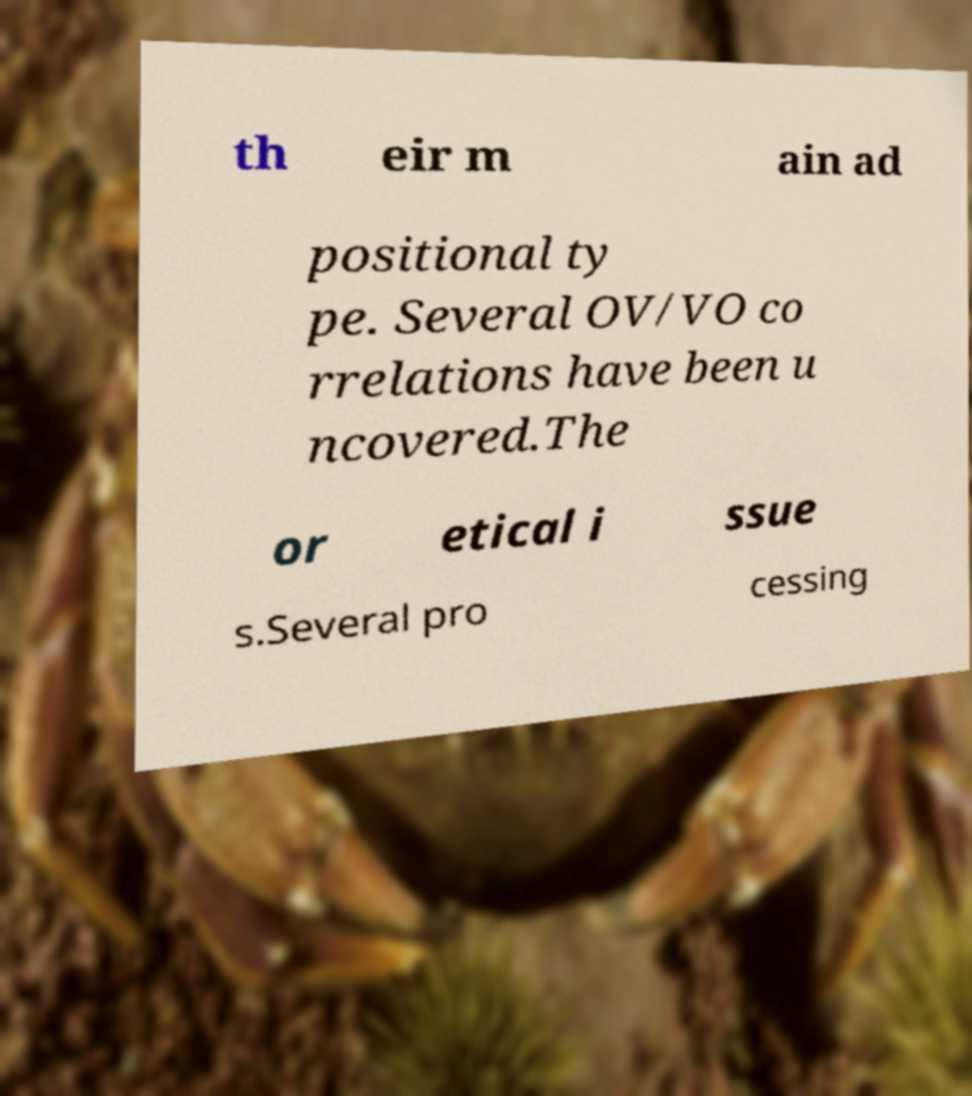Could you extract and type out the text from this image? th eir m ain ad positional ty pe. Several OV/VO co rrelations have been u ncovered.The or etical i ssue s.Several pro cessing 